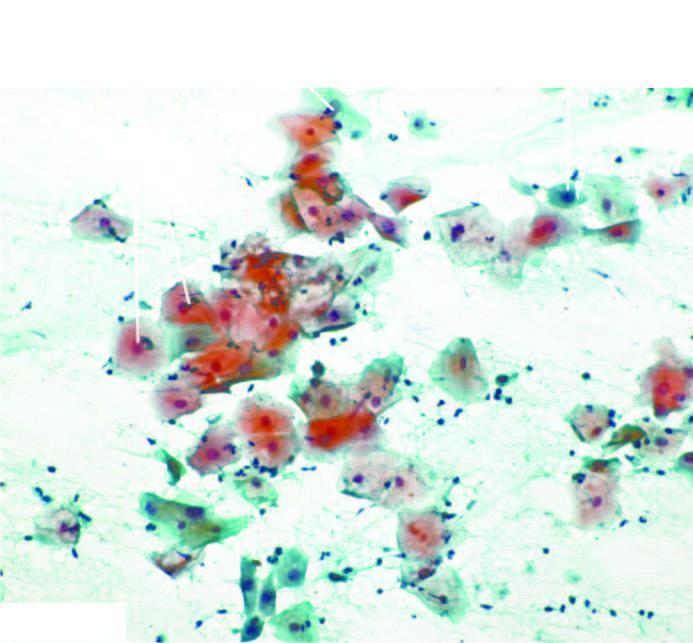what is various types of epithelial cells seen in?
Answer the question using a single word or phrase. Normal pap smear 